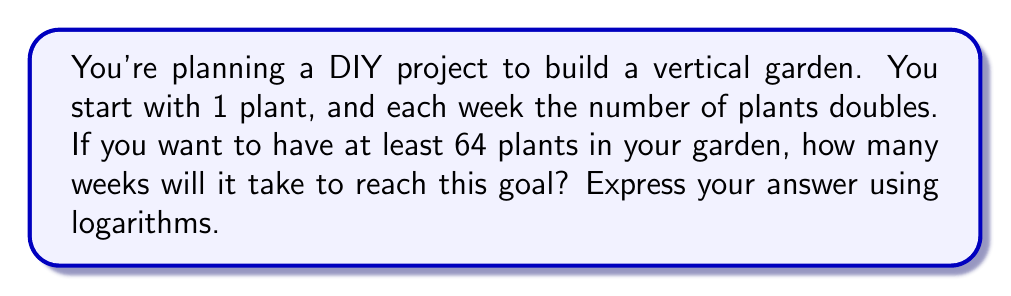Solve this math problem. Let's approach this step-by-step:

1) We start with 1 plant and double each week. This can be represented by the exponential function:

   $N = 2^t$

   Where $N$ is the number of plants and $t$ is the number of weeks.

2) We want to find when $N$ is at least 64. So we can set up the equation:

   $64 = 2^t$

3) To solve for $t$, we can use logarithms. Taking the log base 2 of both sides:

   $\log_2(64) = \log_2(2^t)$

4) Using the logarithm property $\log_a(a^x) = x$, we get:

   $\log_2(64) = t$

5) We can calculate $\log_2(64)$:

   $64 = 2^6$, so $\log_2(64) = 6$

Therefore, $t = 6$ weeks.

6) To express this using logarithms in the answer, we can write:

   $t = \log_2(64)$
Answer: $t = \log_2(64) = 6$ weeks 